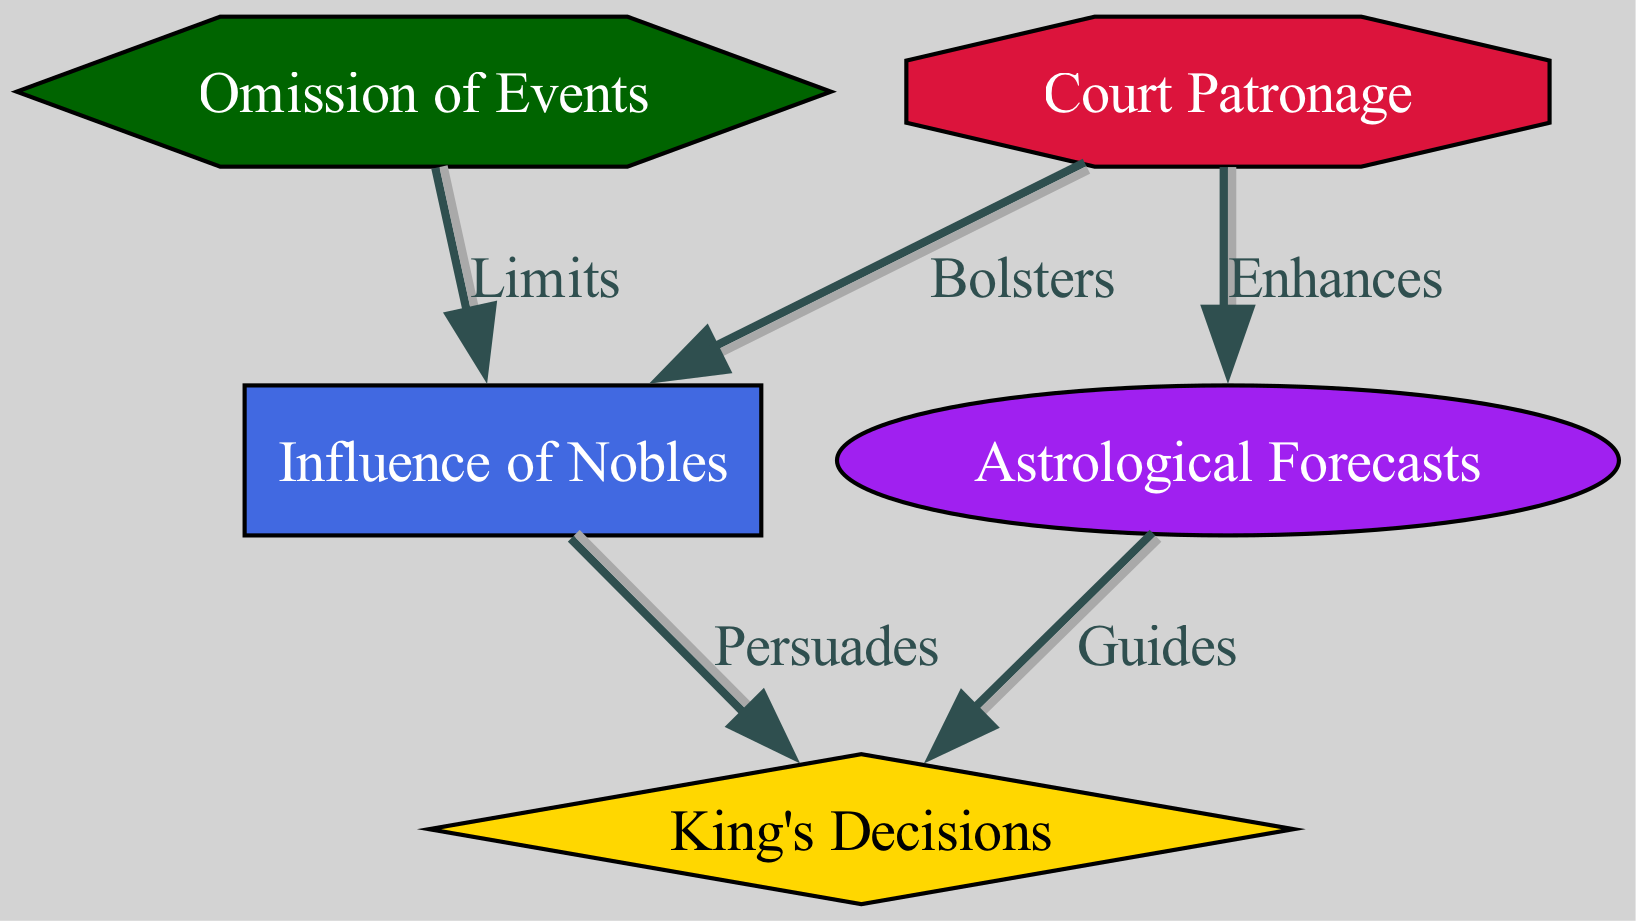What are the five nodes in the diagram? The diagram contains five nodes: King's Decisions, Influence of Nobles, Astrological Forecasts, Omission of Events, and Court Patronage.
Answer: King's Decisions, Influence of Nobles, Astrological Forecasts, Omission of Events, Court Patronage Which node is shaped like a diamond? In the diagram, the node representing King's Decisions is shaped like a diamond, indicating its central importance in the flow of information.
Answer: King's Decisions How many edges are present in the diagram? The diagram has five edges that depict the relationships among the nodes, connecting influences and decisions in the celestial dynamics.
Answer: 5 What influence guides the King's Decisions? Astrological Forecasts are indicated to guide the King's Decisions, as shown by the directed edge between them.
Answer: Astrological Forecasts What is the relationship between Omission of Events and the influence of Nobles? The Omission of Events is shown to limit the Influence of Nobles, indicating that when events are omitted, the influence of nobles may be curtailed.
Answer: Limits Which node enhances Astrological Forecasts? Court Patronage is identified as the influence that enhances Astrological Forecasts, suggesting that the support for astrology comes from the royal patronage.
Answer: Court Patronage If Omission of Events occurs, how does it affect the Nobles' influence? When Omission of Events occurs, it limits the Influence of Nobles, suggesting that lack of acknowledgment of certain events can reduce their ability to persuade the King.
Answer: Limits What is the primary role of the Influence of Nobles over the King's Decisions? The Influence of Nobles primarily persuades the King's Decisions, illustrating their important role in advising and influencing monarchy decisions.
Answer: Persuades 